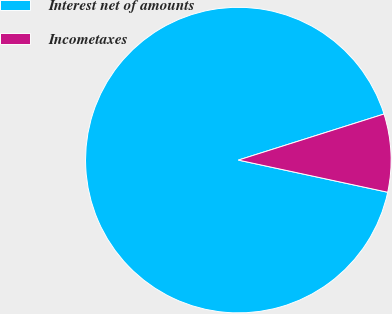<chart> <loc_0><loc_0><loc_500><loc_500><pie_chart><fcel>Interest net of amounts<fcel>Incometaxes<nl><fcel>91.75%<fcel>8.25%<nl></chart> 